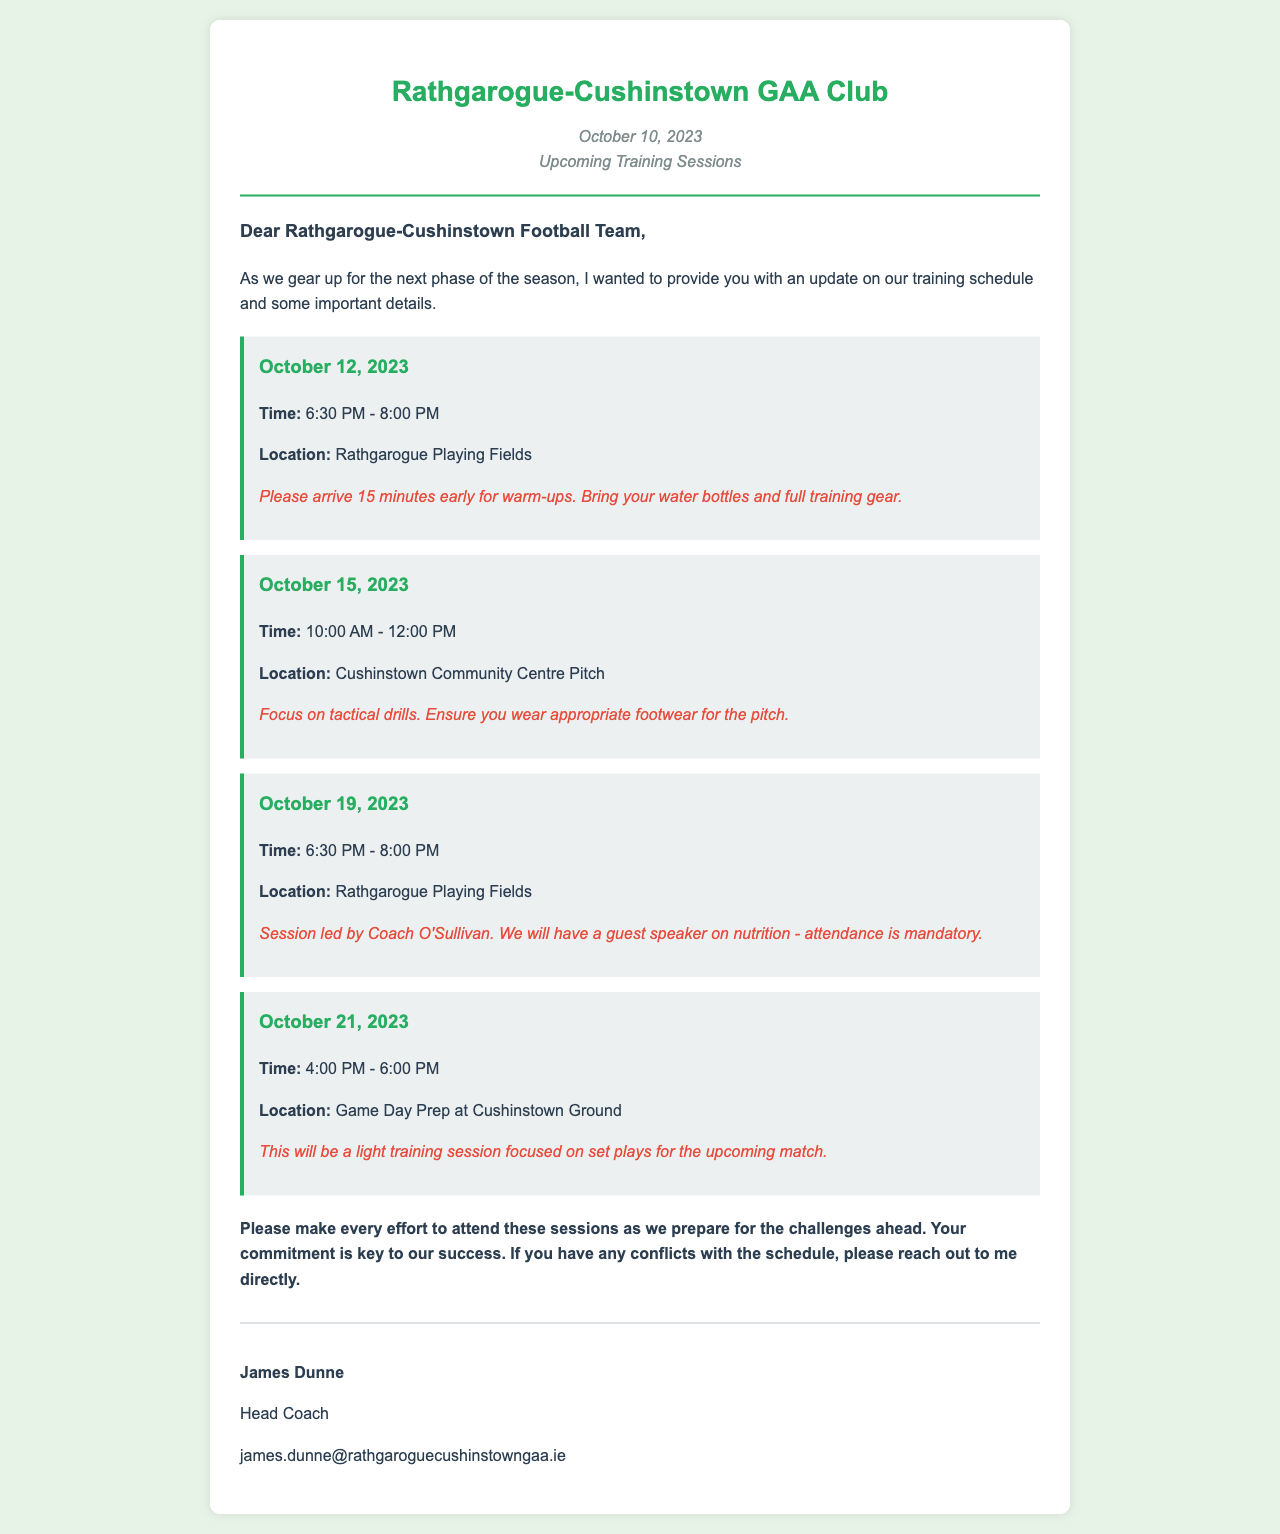What is the date of the first training session? The first training session is scheduled for October 12, 2023.
Answer: October 12, 2023 What time does the training session on October 15, 2023, start? The training session on October 15, 2023, starts at 10:00 AM.
Answer: 10:00 AM Where will the training session on October 19, 2023, take place? The training session on October 19, 2023, will take place at Rathgarogue Playing Fields.
Answer: Rathgarogue Playing Fields What is the special instruction for the session on October 21, 2023? The special instruction for the session on October 21, 2023, is to focus on set plays for the upcoming match.
Answer: Focus on set plays for the upcoming match Who is leading the training session on October 19, 2023? Coach O'Sullivan is leading the training session on October 19, 2023.
Answer: Coach O'Sullivan How long is the training session scheduled for October 12, 2023? The training session scheduled for October 12, 2023, is 1 hour and 30 minutes long.
Answer: 1 hour and 30 minutes What should players bring to the training session on October 12, 2023? Players should bring their water bottles and full training gear to the training session on October 12, 2023.
Answer: Water bottles and full training gear Why is attendance mandatory for the session on October 19, 2023? Attendance is mandatory for the session on October 19, 2023, because there will be a guest speaker on nutrition.
Answer: Guest speaker on nutrition What should players do if they have conflicts with the training schedule? Players should reach out directly to the coach if they have conflicts with the training schedule.
Answer: Reach out to the coach 